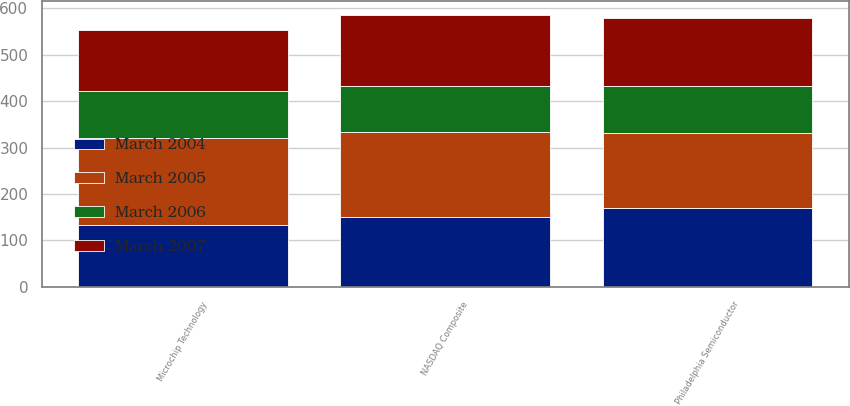<chart> <loc_0><loc_0><loc_500><loc_500><stacked_bar_chart><ecel><fcel>Microchip Technology<fcel>NASDAQ Composite<fcel>Philadelphia Semiconductor<nl><fcel>March 2006<fcel>100<fcel>100<fcel>100<nl><fcel>March 2004<fcel>133.3<fcel>151.41<fcel>170.76<nl><fcel>March 2007<fcel>132.21<fcel>152.88<fcel>146.74<nl><fcel>March 2005<fcel>187.86<fcel>181.51<fcel>161.55<nl></chart> 